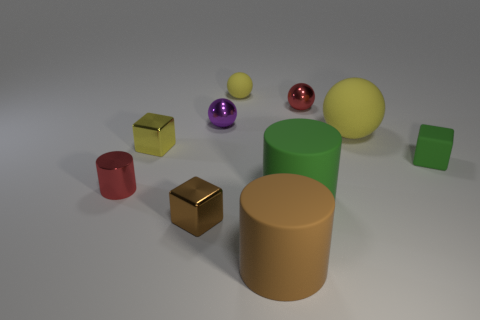Is the number of large green objects right of the large yellow object greater than the number of brown shiny things that are on the right side of the matte cube?
Your answer should be compact. No. What color is the large matte cylinder that is behind the small brown thing?
Your answer should be very brief. Green. There is a matte cylinder in front of the small brown metallic block; is its size the same as the green matte thing that is in front of the red cylinder?
Provide a short and direct response. Yes. What number of things are rubber spheres or purple rubber objects?
Provide a succinct answer. 2. There is a tiny red object that is left of the tiny red thing that is on the right side of the small purple shiny thing; what is its material?
Make the answer very short. Metal. What number of green rubber objects are the same shape as the big yellow rubber object?
Provide a succinct answer. 0. Are there any tiny shiny things that have the same color as the small rubber cube?
Your response must be concise. No. How many objects are red things in front of the tiny red sphere or tiny balls to the left of the big brown matte object?
Offer a terse response. 3. There is a brown object left of the brown rubber thing; is there a purple sphere on the left side of it?
Provide a succinct answer. No. What shape is the green rubber object that is the same size as the red metal cylinder?
Provide a short and direct response. Cube. 